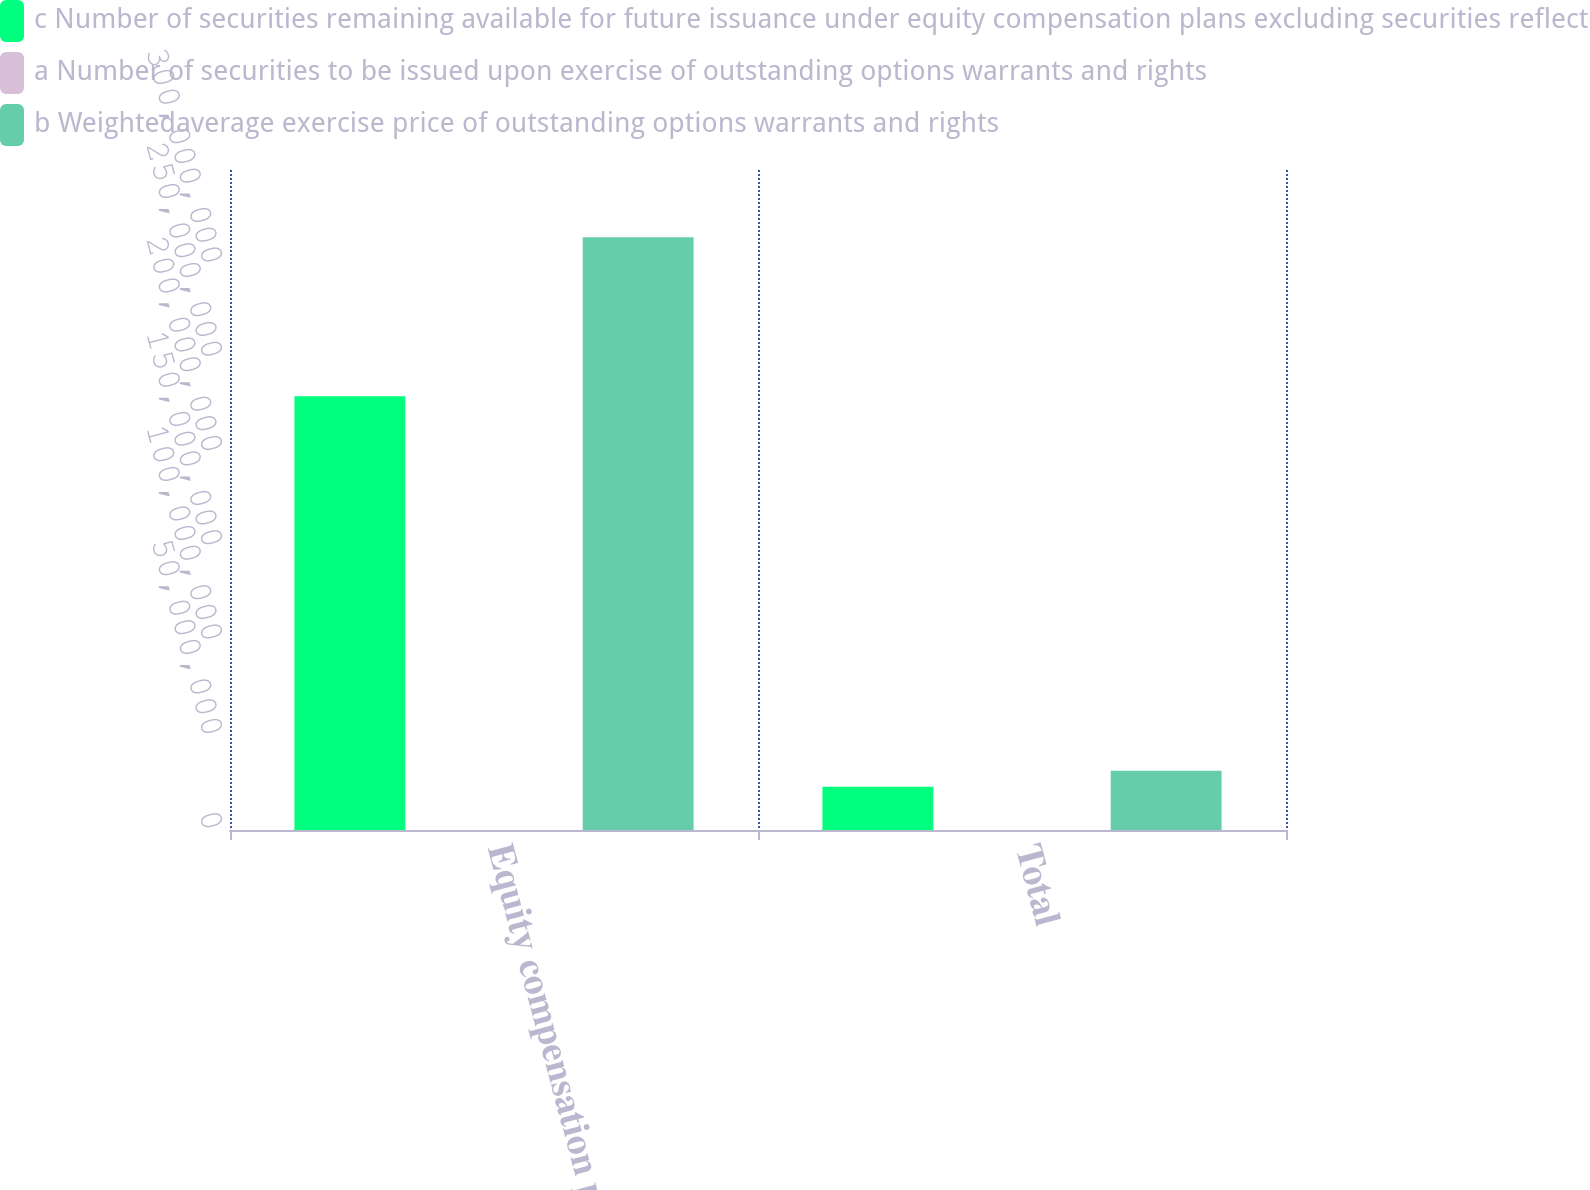<chart> <loc_0><loc_0><loc_500><loc_500><stacked_bar_chart><ecel><fcel>Equity compensation plans<fcel>Total<nl><fcel>c Number of securities remaining available for future issuance under equity compensation plans excluding securities reflected in columna<fcel>2.29964e+08<fcel>2.29964e+07<nl><fcel>a Number of securities to be issued upon exercise of outstanding options warrants and rights<fcel>43.47<fcel>43.47<nl><fcel>b Weightedaverage exercise price of outstanding options warrants and rights<fcel>3.14372e+08<fcel>3.14372e+07<nl></chart> 